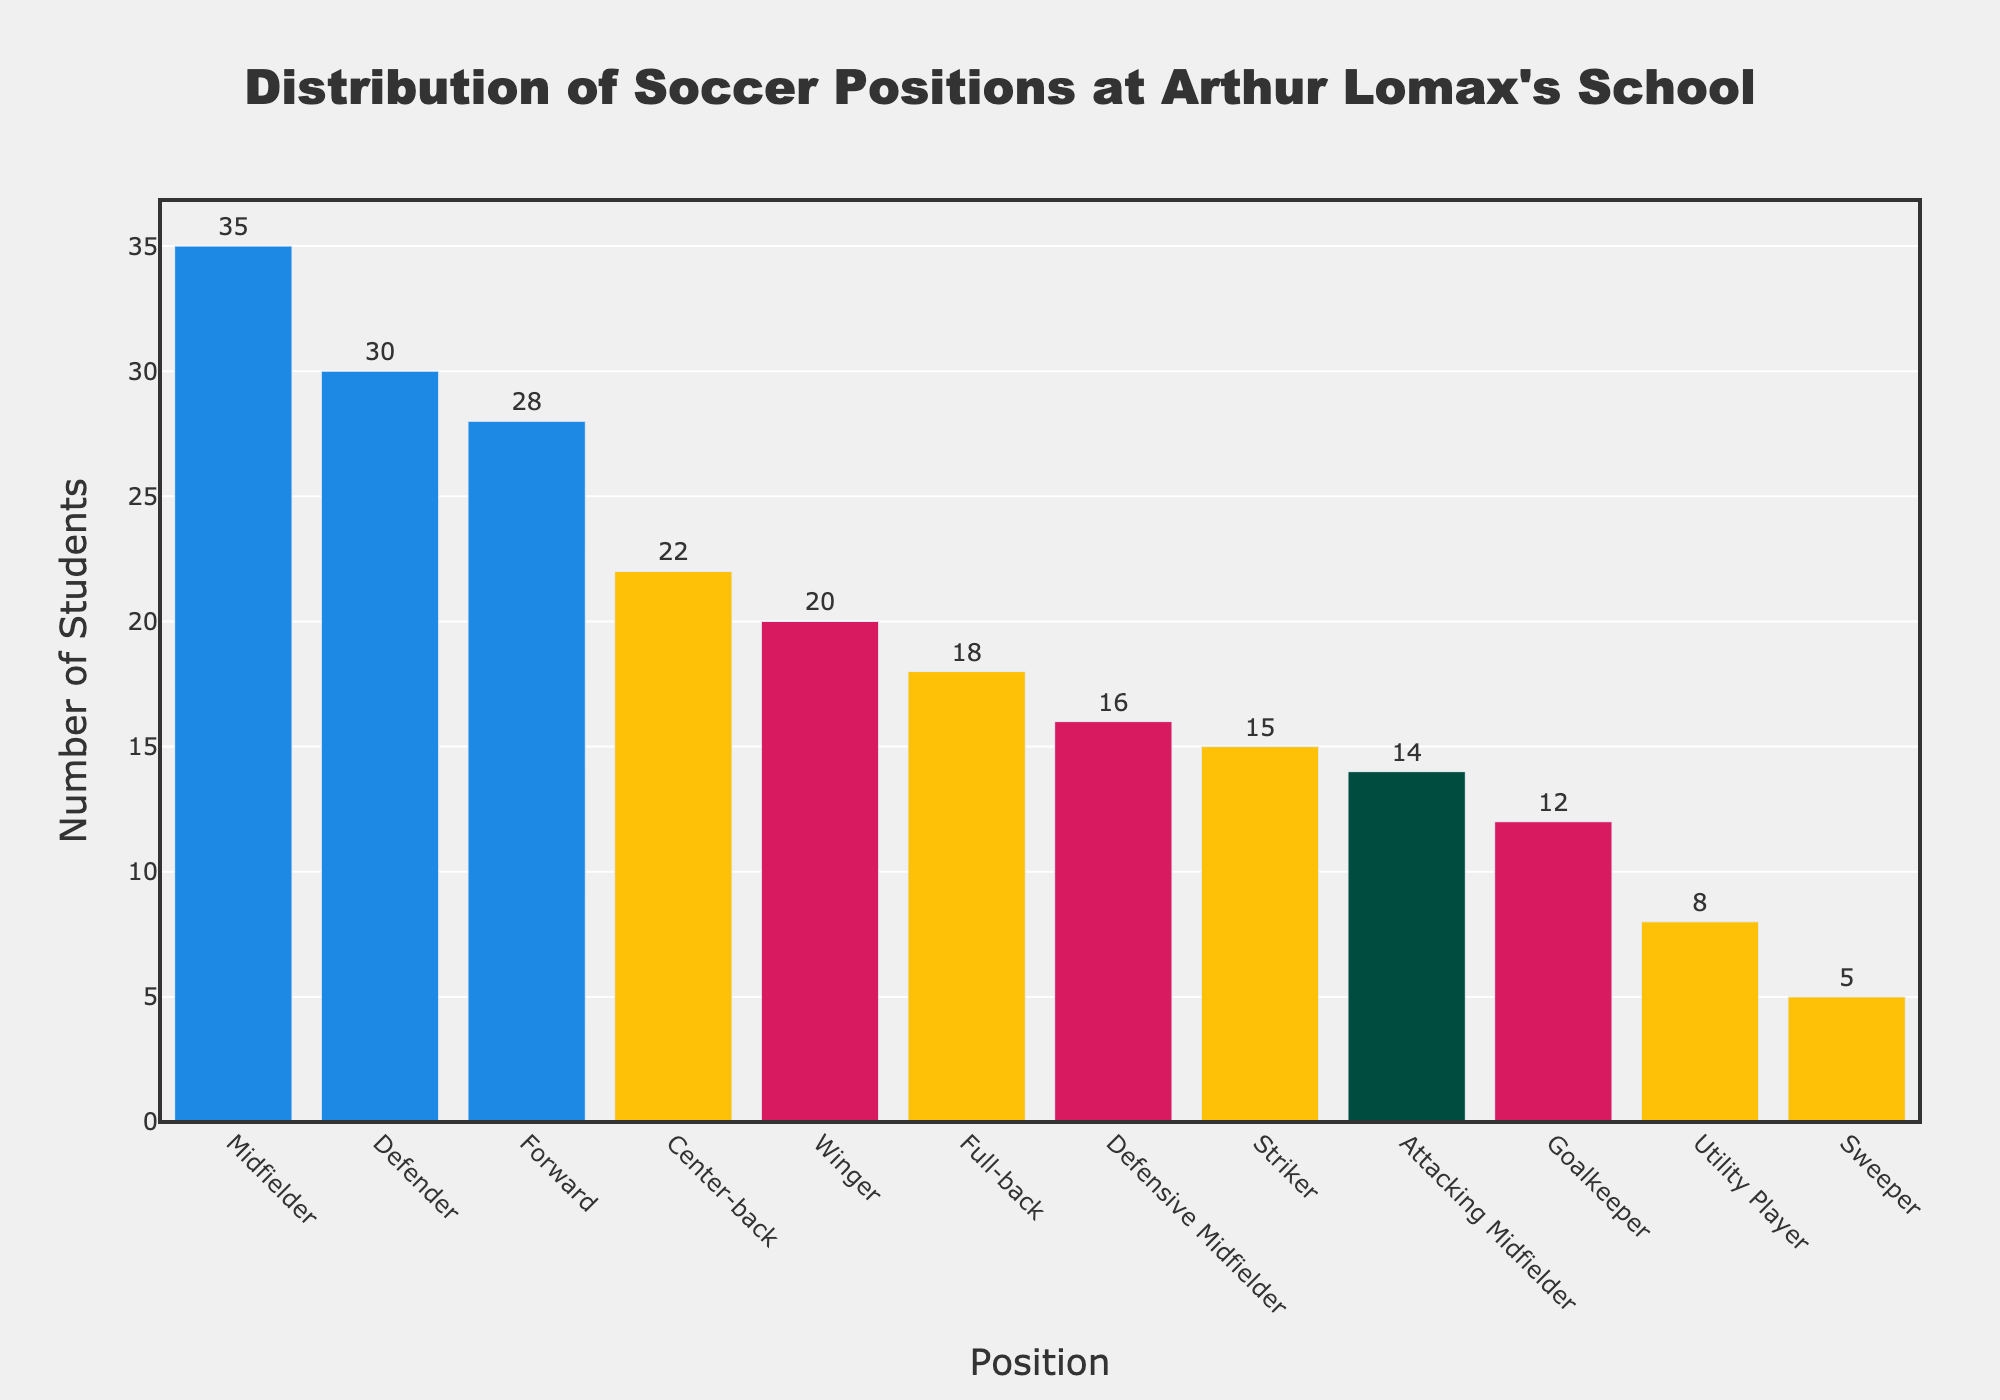Which soccer position has the highest number of students? By inspecting the bar chart, the Midfielder position has the highest bar compared to other positions. Therefore, the Midfielder has the highest number of students.
Answer: Midfielder Which position has fewer students, Goalkeeper or Center-back? From the bar chart, the height of the bar representing the Goalkeeper is shorter compared to the Center-back. Thus, Goalkeeper has fewer students.
Answer: Goalkeeper What is the combined total of students for the Forward and Striker positions? The number of students for Forward is 28, and for Striker is 15. Adding them together gives 28 + 15 = 43.
Answer: 43 Is the number of students in the Utility Player position greater than in the Sweeper position? By comparing the bar heights, the Utility Player has a taller bar than the Sweeper, indicating that there are more students in the Utility Player position than in the Sweeper position.
Answer: Yes Which positional category has the lowest number of students? The bar for the Sweeper position is the lowest among all the positions displayed in the chart, indicating it has the fewest students.
Answer: Sweeper How many more students are there in the Winger position compared to the Full-back position? The number of students in the Winger position is 20, and in the Full-back position is 18. The difference is 20 - 18 = 2.
Answer: 2 If the Defender and Center-back positions were combined, what would be their total number of students? The number of students for the Defender is 30 and for the Center-back is 22. Combining these gives 30 + 22 = 52.
Answer: 52 Are there more students playing in Attacking Midfielder or Defensive Midfielder positions? Comparing the heights of the bars, the Attacking Midfielder position has a shorter bar compared to the Defensive Midfielder. Thus, there are more students in the Defensive Midfielder position.
Answer: Defensive Midfielder What is the difference in the number of students between the Midfielder and Goalkeeper positions? The number of students for Midfielder is 35 and for Goalkeeper is 12. The difference is 35 - 12 = 23.
Answer: 23 